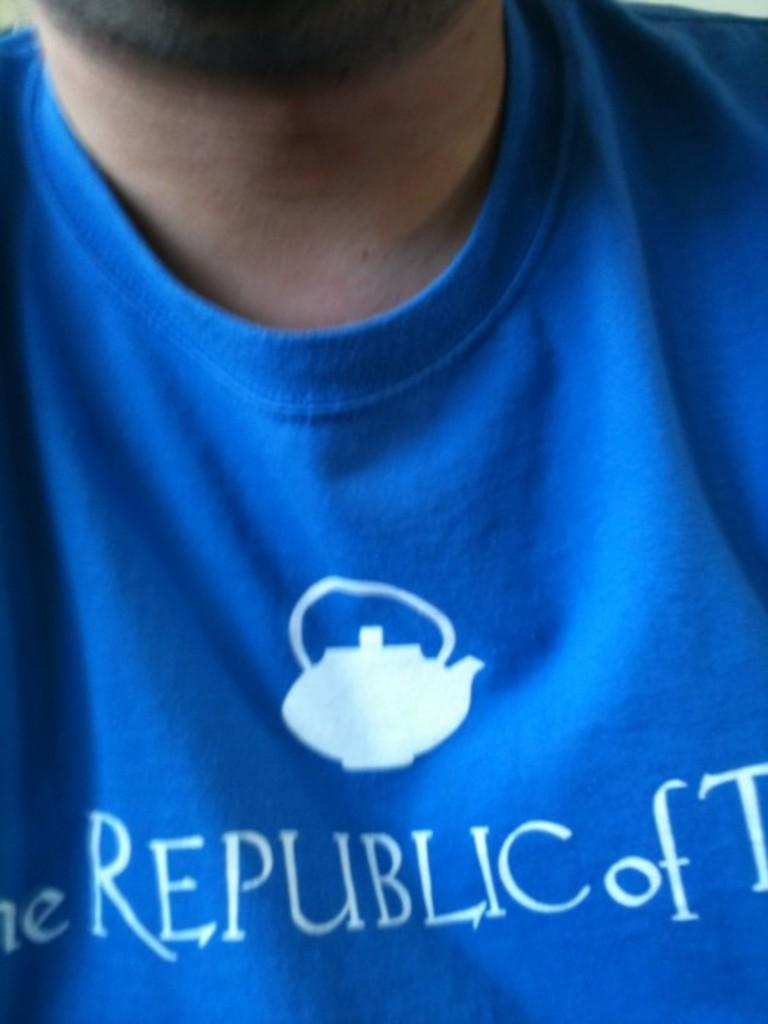Who or what is the main subject of the image? There is a person in the image. What is the person wearing in the image? The person is wearing a blue t-shirt. Can you describe any additional details about the t-shirt? Yes, there is text on the t-shirt. How does the person's nerve affect the development of the visitor in the image? There is no mention of a nerve, development, or visitor in the image; it only features a person wearing a blue t-shirt with text on it. 